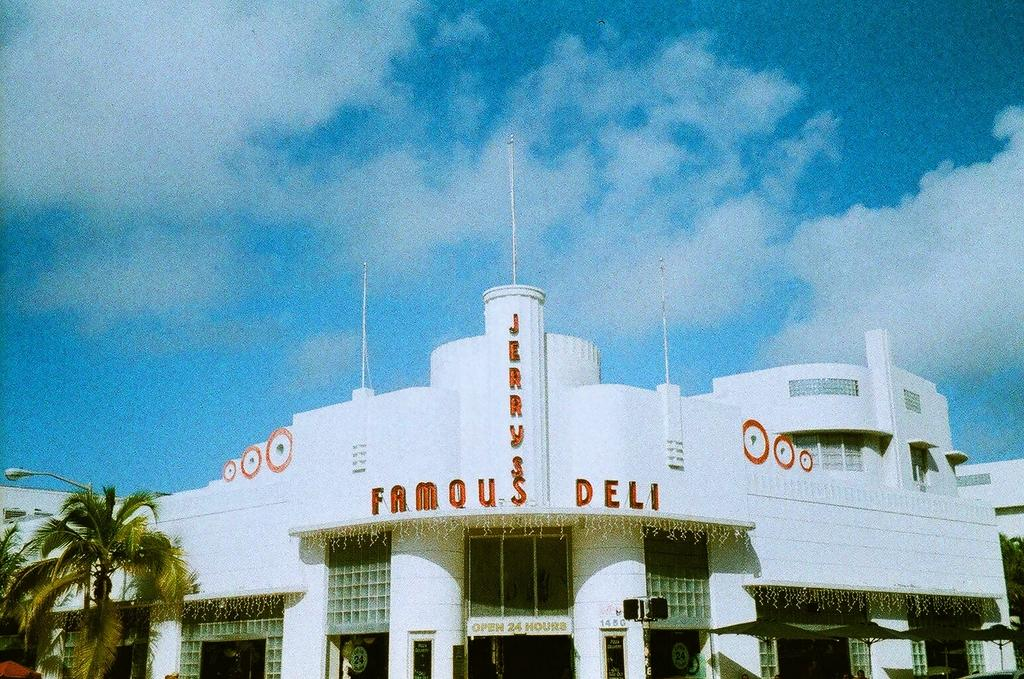Provide a one-sentence caption for the provided image. white building that reads famous deli in red. 